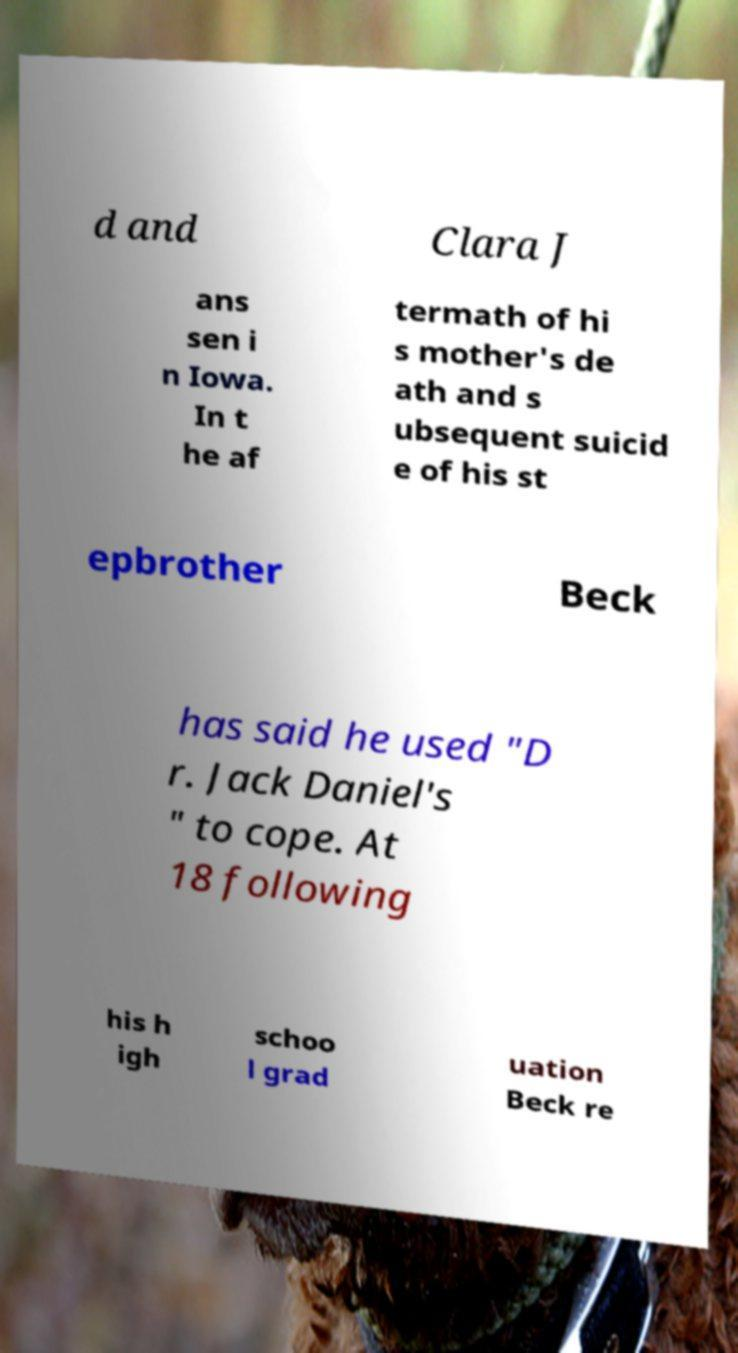Can you read and provide the text displayed in the image?This photo seems to have some interesting text. Can you extract and type it out for me? d and Clara J ans sen i n Iowa. In t he af termath of hi s mother's de ath and s ubsequent suicid e of his st epbrother Beck has said he used "D r. Jack Daniel's " to cope. At 18 following his h igh schoo l grad uation Beck re 